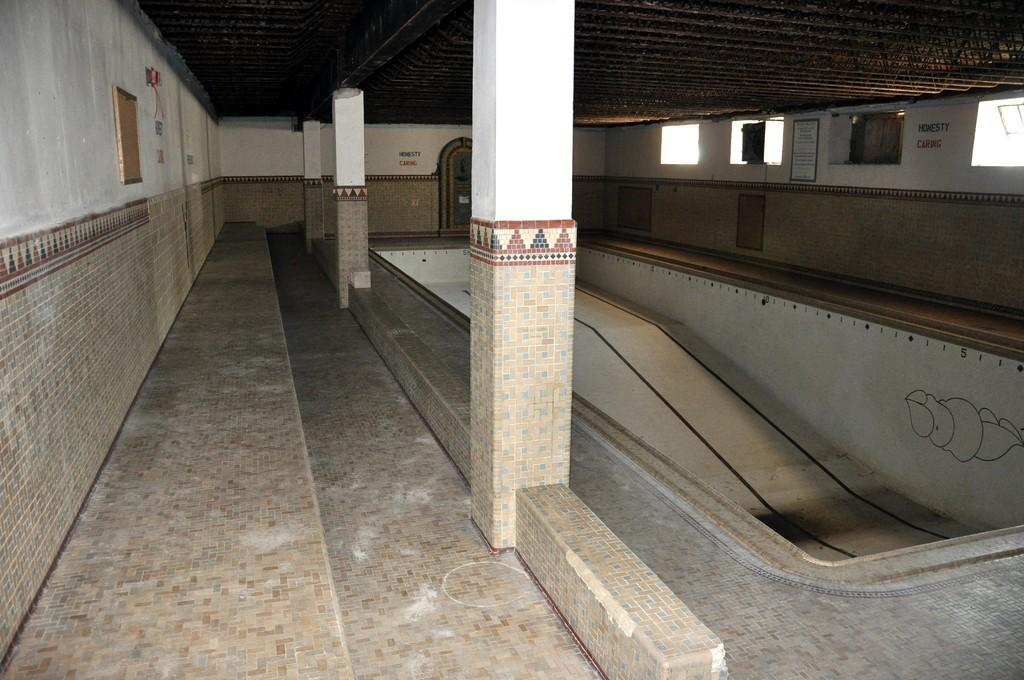What architectural elements can be seen in the image? There are pillars in the image. What other objects can be found in the image? There are boards in the image. What is written on the walls in the image? Texts are written on the walls in the image. What type of surface is present in the image? The image contains a slope surface. What allows natural light to enter the space in the image? There are windows in the image. Can you see a tiger or a donkey in the image? No, there are no animals present in the image. Is this image taken at an airport? The provided facts do not mention any airport or transportation-related elements, so it cannot be determined from the image. 